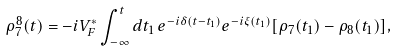Convert formula to latex. <formula><loc_0><loc_0><loc_500><loc_500>\rho _ { 7 } ^ { 8 } ( t ) = - i V _ { F } ^ { * } \int _ { - \infty } ^ { t } d t _ { 1 } \, e ^ { - i \delta ( t - t _ { 1 } ) } e ^ { - i \xi ( t _ { 1 } ) } [ \rho _ { 7 } ( t _ { 1 } ) - \rho _ { 8 } ( t _ { 1 } ) ] ,</formula> 